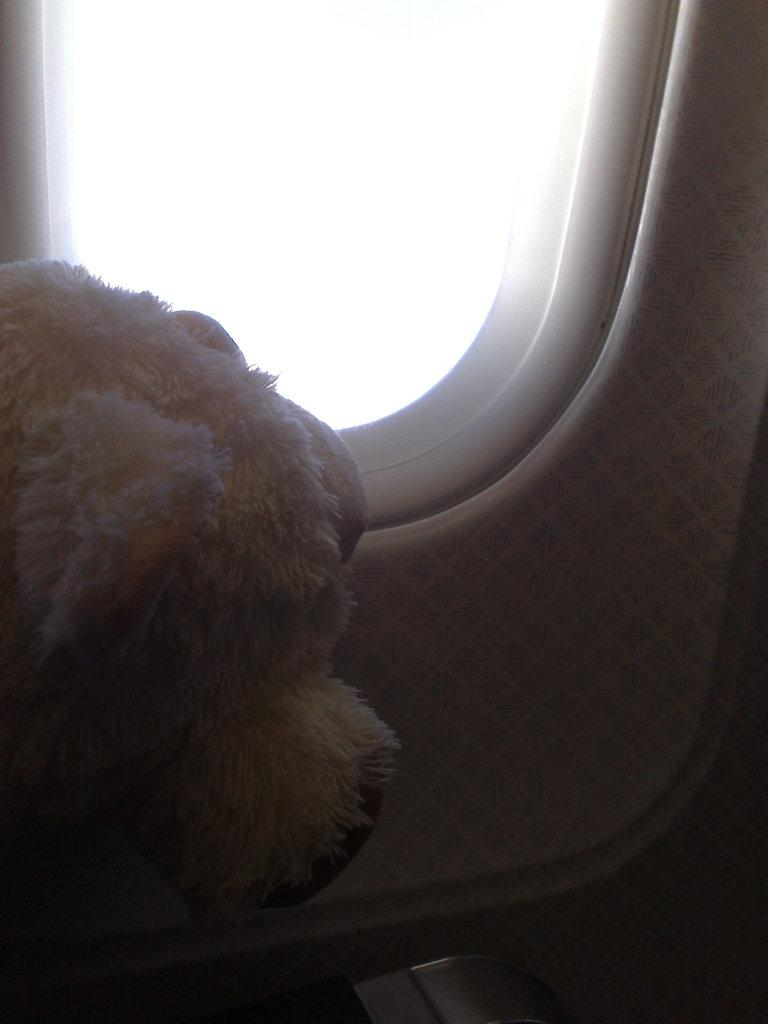What object can be seen on the left side of the image? There is a soft toy in the left side of the image. What type of window is depicted in the image? The image depicts the window of an airplane. What type of eggs can be seen in the image? There are no eggs present in the image. What border is visible in the image? The image does not depict any borders; it shows the window of an airplane. 